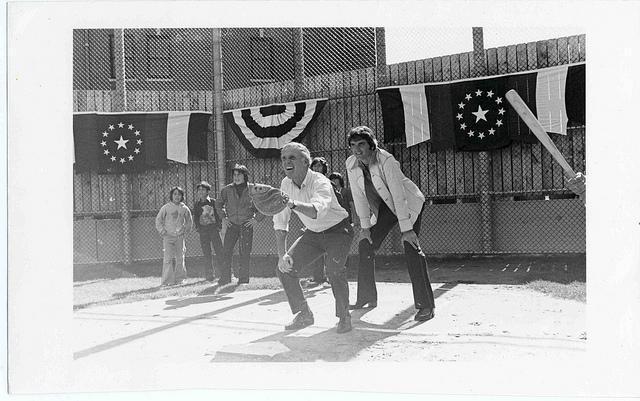How many people are there?
Give a very brief answer. 4. 